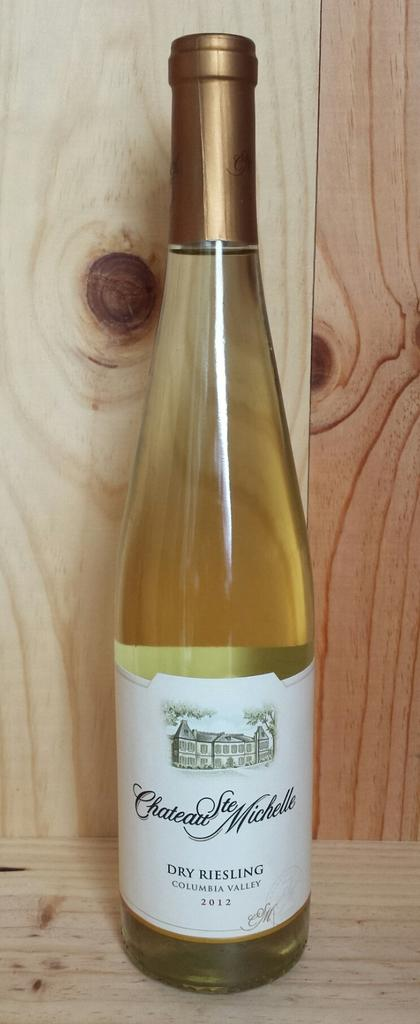<image>
Write a terse but informative summary of the picture. Yellow bottle of wine which says "Dry Riesling" on it. 